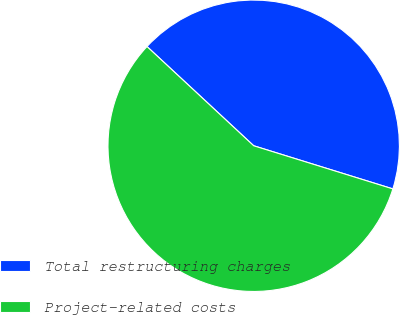Convert chart. <chart><loc_0><loc_0><loc_500><loc_500><pie_chart><fcel>Total restructuring charges<fcel>Project-related costs<nl><fcel>42.86%<fcel>57.14%<nl></chart> 